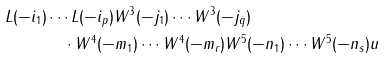<formula> <loc_0><loc_0><loc_500><loc_500>L ( - i _ { 1 } ) & \cdots L ( - i _ { p } ) W ^ { 3 } ( - j _ { 1 } ) \cdots W ^ { 3 } ( - j _ { q } ) \\ & \quad \cdot W ^ { 4 } ( - m _ { 1 } ) \cdots W ^ { 4 } ( - m _ { r } ) W ^ { 5 } ( - n _ { 1 } ) \cdots W ^ { 5 } ( - n _ { s } ) u</formula> 